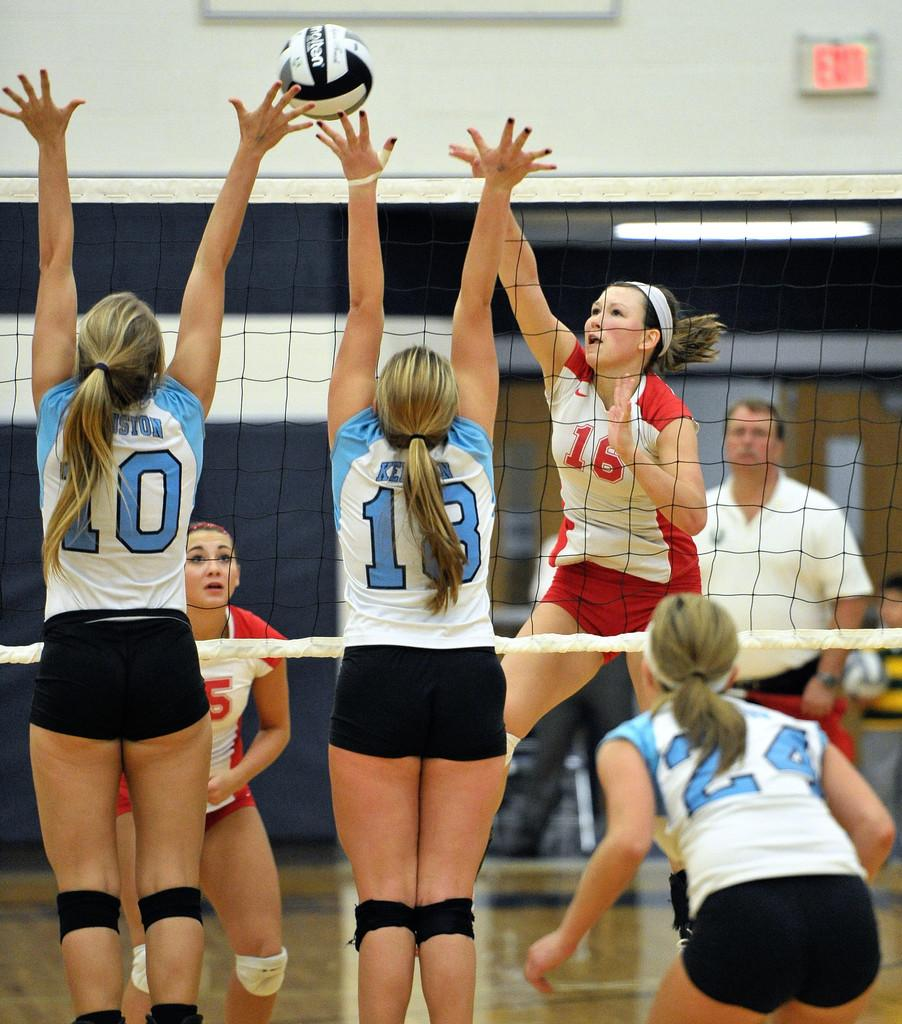<image>
Write a terse but informative summary of the picture. a player that has the number 10 on their jersey 